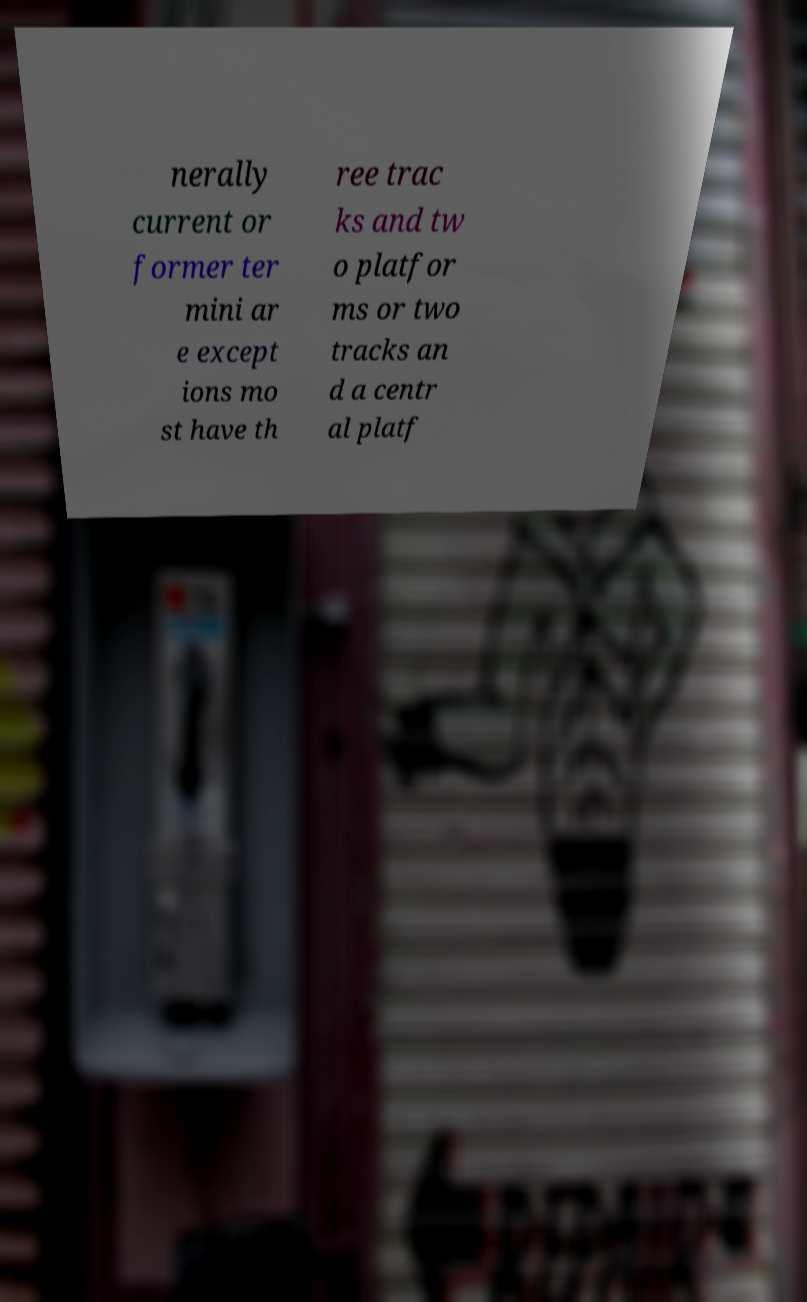Can you accurately transcribe the text from the provided image for me? nerally current or former ter mini ar e except ions mo st have th ree trac ks and tw o platfor ms or two tracks an d a centr al platf 